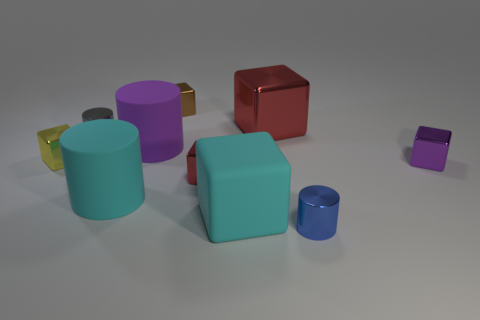Are there any other things that have the same material as the tiny yellow block?
Offer a terse response. Yes. The purple object that is behind the small block that is to the left of the small metallic cube behind the yellow shiny object is made of what material?
Offer a terse response. Rubber. The large thing that is both to the left of the tiny red object and behind the purple cube is made of what material?
Keep it short and to the point. Rubber. What number of large red metallic things are the same shape as the gray metallic object?
Keep it short and to the point. 0. There is a shiny cylinder behind the small metallic cylinder that is on the right side of the gray metallic thing; how big is it?
Keep it short and to the point. Small. There is a cube that is right of the large shiny cube; is it the same color as the shiny cylinder that is behind the tiny yellow thing?
Provide a short and direct response. No. There is a tiny metal cylinder on the left side of the metallic object that is in front of the small red thing; what number of tiny red blocks are to the right of it?
Offer a very short reply. 1. How many small shiny blocks are both behind the tiny red object and to the left of the big red metallic cube?
Your answer should be compact. 2. Is the number of tiny cubes to the right of the small purple metal block greater than the number of shiny cubes?
Give a very brief answer. No. What number of purple metallic objects have the same size as the yellow metal block?
Offer a very short reply. 1. 